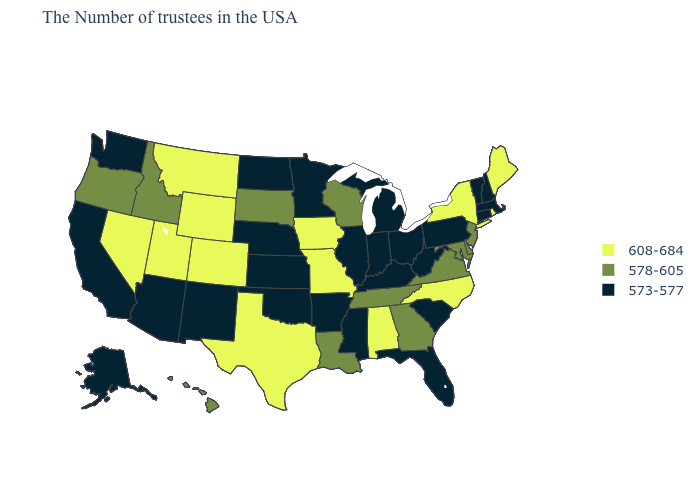What is the value of Washington?
Quick response, please. 573-577. Does Montana have the highest value in the USA?
Be succinct. Yes. Name the states that have a value in the range 573-577?
Give a very brief answer. Massachusetts, New Hampshire, Vermont, Connecticut, Pennsylvania, South Carolina, West Virginia, Ohio, Florida, Michigan, Kentucky, Indiana, Illinois, Mississippi, Arkansas, Minnesota, Kansas, Nebraska, Oklahoma, North Dakota, New Mexico, Arizona, California, Washington, Alaska. Does Illinois have the highest value in the MidWest?
Answer briefly. No. What is the value of New Hampshire?
Answer briefly. 573-577. What is the value of Wyoming?
Quick response, please. 608-684. Does California have the lowest value in the USA?
Keep it brief. Yes. Which states have the highest value in the USA?
Concise answer only. Maine, Rhode Island, New York, North Carolina, Alabama, Missouri, Iowa, Texas, Wyoming, Colorado, Utah, Montana, Nevada. What is the highest value in the South ?
Quick response, please. 608-684. What is the highest value in the USA?
Answer briefly. 608-684. Does Maine have the highest value in the USA?
Write a very short answer. Yes. What is the highest value in the Northeast ?
Short answer required. 608-684. Does North Dakota have a lower value than Louisiana?
Give a very brief answer. Yes. Among the states that border New Jersey , does Pennsylvania have the lowest value?
Concise answer only. Yes. Name the states that have a value in the range 573-577?
Keep it brief. Massachusetts, New Hampshire, Vermont, Connecticut, Pennsylvania, South Carolina, West Virginia, Ohio, Florida, Michigan, Kentucky, Indiana, Illinois, Mississippi, Arkansas, Minnesota, Kansas, Nebraska, Oklahoma, North Dakota, New Mexico, Arizona, California, Washington, Alaska. 